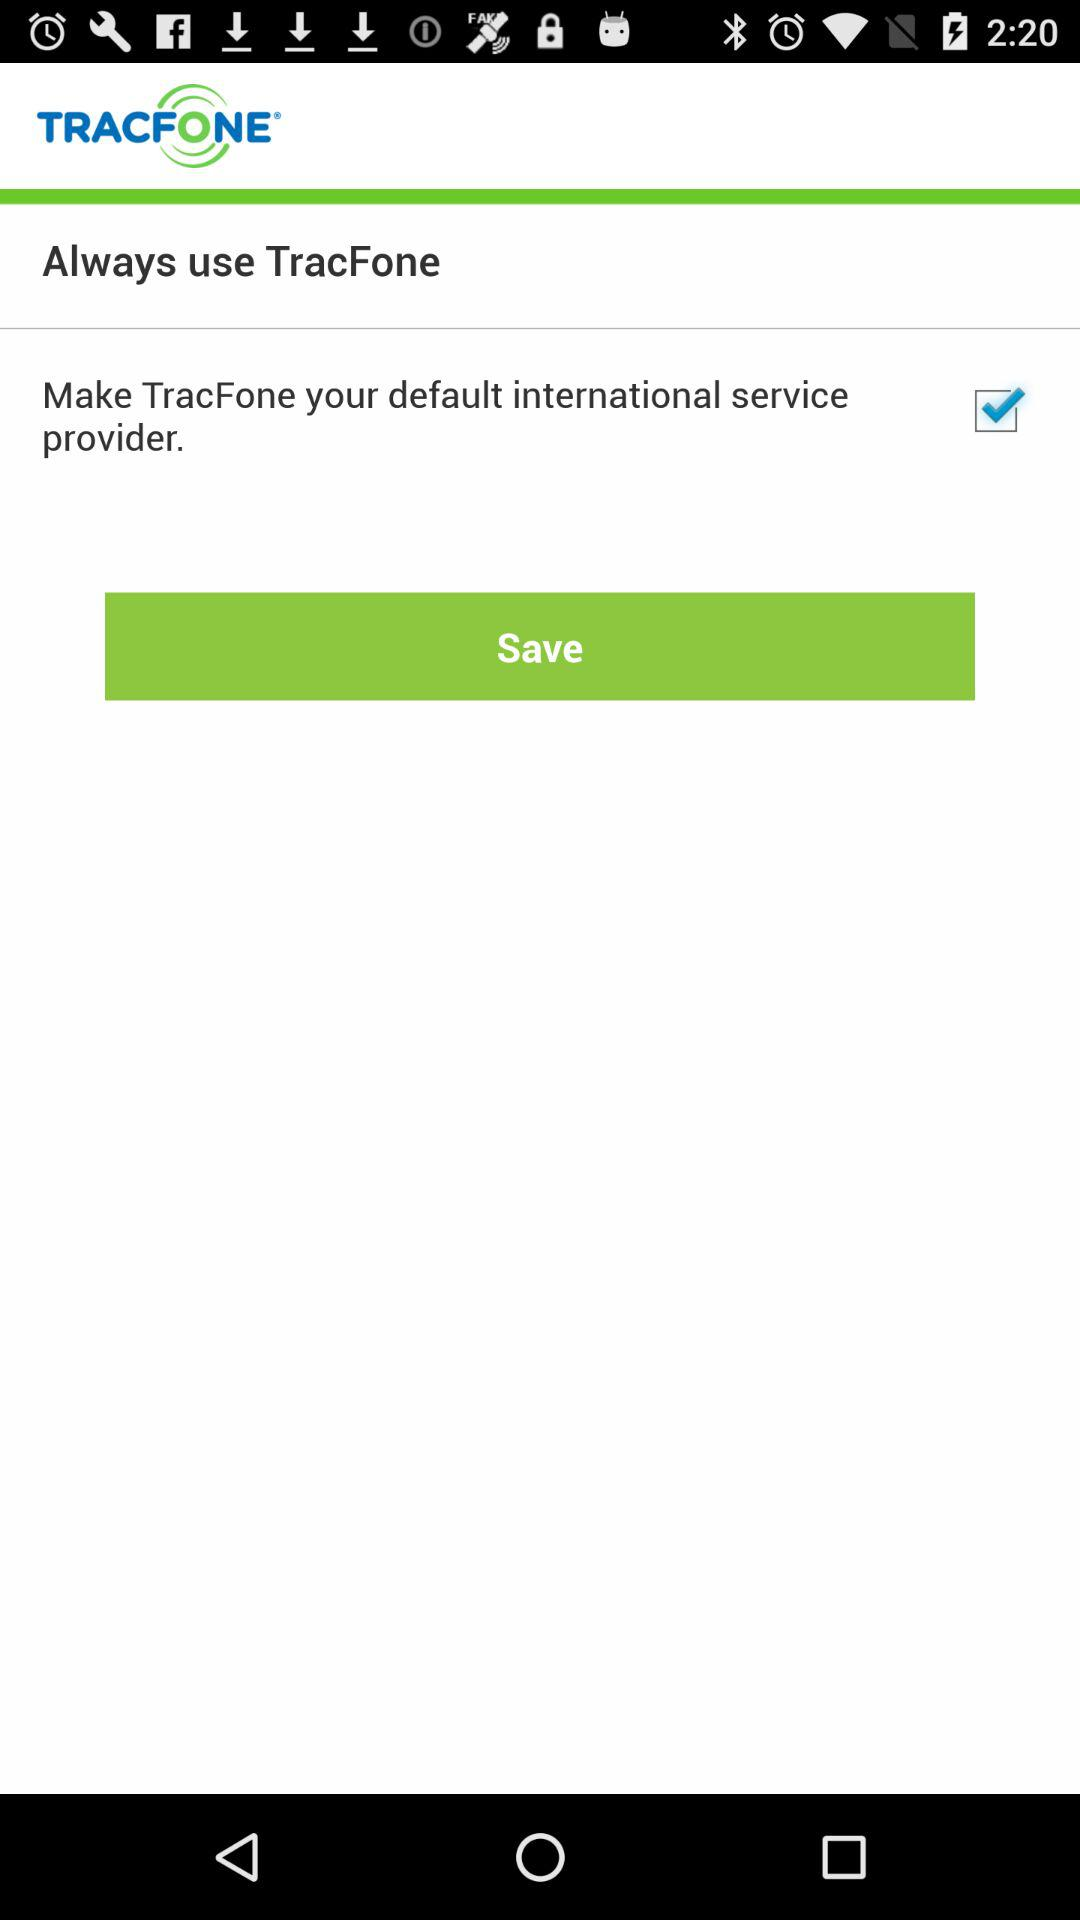What is the selected option? The selected option is "Make TracFone your default international service provider". 